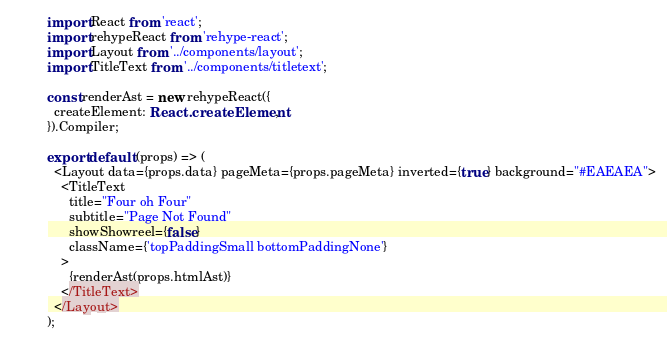<code> <loc_0><loc_0><loc_500><loc_500><_TypeScript_>import React from 'react';
import rehypeReact from 'rehype-react';
import Layout from '../components/layout';
import TitleText from '../components/titletext';

const renderAst = new rehypeReact({
  createElement: React.createElement,
}).Compiler;

export default (props) => (
  <Layout data={props.data} pageMeta={props.pageMeta} inverted={true} background="#EAEAEA">
    <TitleText
      title="Four oh Four"
      subtitle="Page Not Found"
      showShowreel={false}
      className={'topPaddingSmall bottomPaddingNone'}
    >
      {renderAst(props.htmlAst)}
    </TitleText>
  </Layout>
);
</code> 